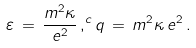<formula> <loc_0><loc_0><loc_500><loc_500>\varepsilon \, = \, \frac { m ^ { 2 } \kappa } { e ^ { 2 } } \, , ^ { c } q \, = \, m ^ { 2 } \kappa \, e ^ { 2 } \, .</formula> 